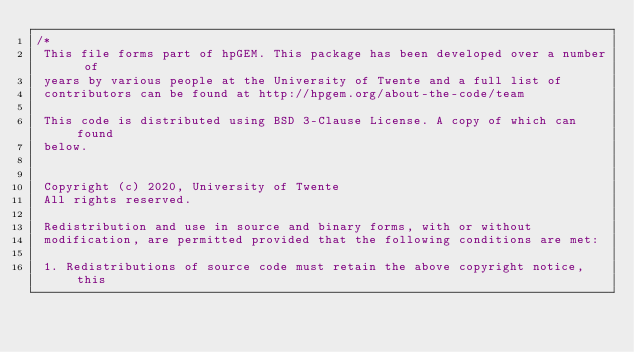Convert code to text. <code><loc_0><loc_0><loc_500><loc_500><_C++_>/*
 This file forms part of hpGEM. This package has been developed over a number of
 years by various people at the University of Twente and a full list of
 contributors can be found at http://hpgem.org/about-the-code/team

 This code is distributed using BSD 3-Clause License. A copy of which can found
 below.


 Copyright (c) 2020, University of Twente
 All rights reserved.

 Redistribution and use in source and binary forms, with or without
 modification, are permitted provided that the following conditions are met:

 1. Redistributions of source code must retain the above copyright notice, this</code> 